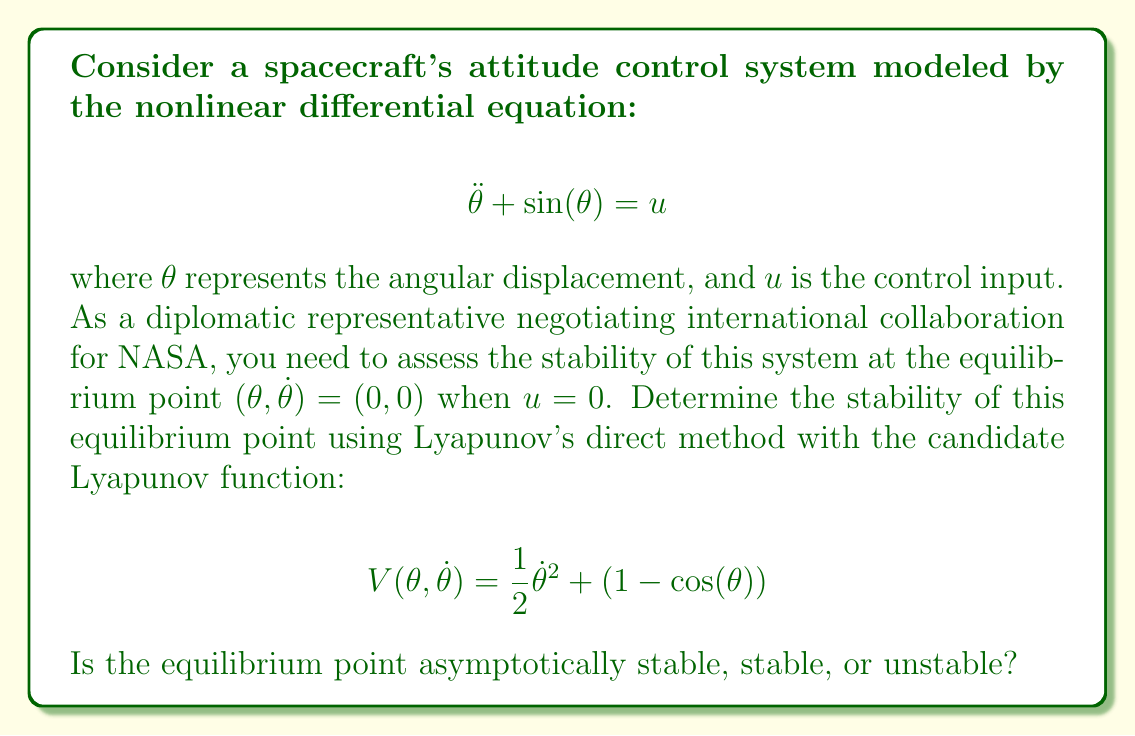Help me with this question. To determine the stability of the equilibrium point using Lyapunov's direct method, we need to analyze the properties of the candidate Lyapunov function $V(\theta, \dot{\theta})$ and its time derivative.

Step 1: Verify that $V(\theta, \dot{\theta})$ is positive definite in the neighborhood of $(0, 0)$.
- $V(0, 0) = 0$
- For small $\theta$ and $\dot{\theta}$, $V(\theta, \dot{\theta}) > 0$ (except at the origin)

Step 2: Calculate the time derivative of $V(\theta, \dot{\theta})$:
$$\begin{align}
\dot{V} &= \frac{\partial V}{\partial \theta}\dot{\theta} + \frac{\partial V}{\partial \dot{\theta}}\ddot{\theta} \\
&= \sin(\theta)\dot{\theta} + \dot{\theta}\ddot{\theta}
\end{align}$$

Step 3: Substitute $\ddot{\theta} = -\sin(\theta)$ from the original equation (with $u = 0$):
$$\begin{align}
\dot{V} &= \sin(\theta)\dot{\theta} + \dot{\theta}(-\sin(\theta)) \\
&= 0
\end{align}$$

Step 4: Analyze the results:
- $V(\theta, \dot{\theta})$ is positive definite in the neighborhood of $(0, 0)$
- $\dot{V}(\theta, \dot{\theta}) = 0$ for all $\theta$ and $\dot{\theta}$

Step 5: Apply Lyapunov's stability theorem:
- Since $V(\theta, \dot{\theta})$ is positive definite and $\dot{V}(\theta, \dot{\theta}) = 0$, the equilibrium point is stable but not asymptotically stable.

This means that trajectories starting near the equilibrium point will remain close to it, but may not converge to it as time approaches infinity.
Answer: Stable (but not asymptotically stable) 